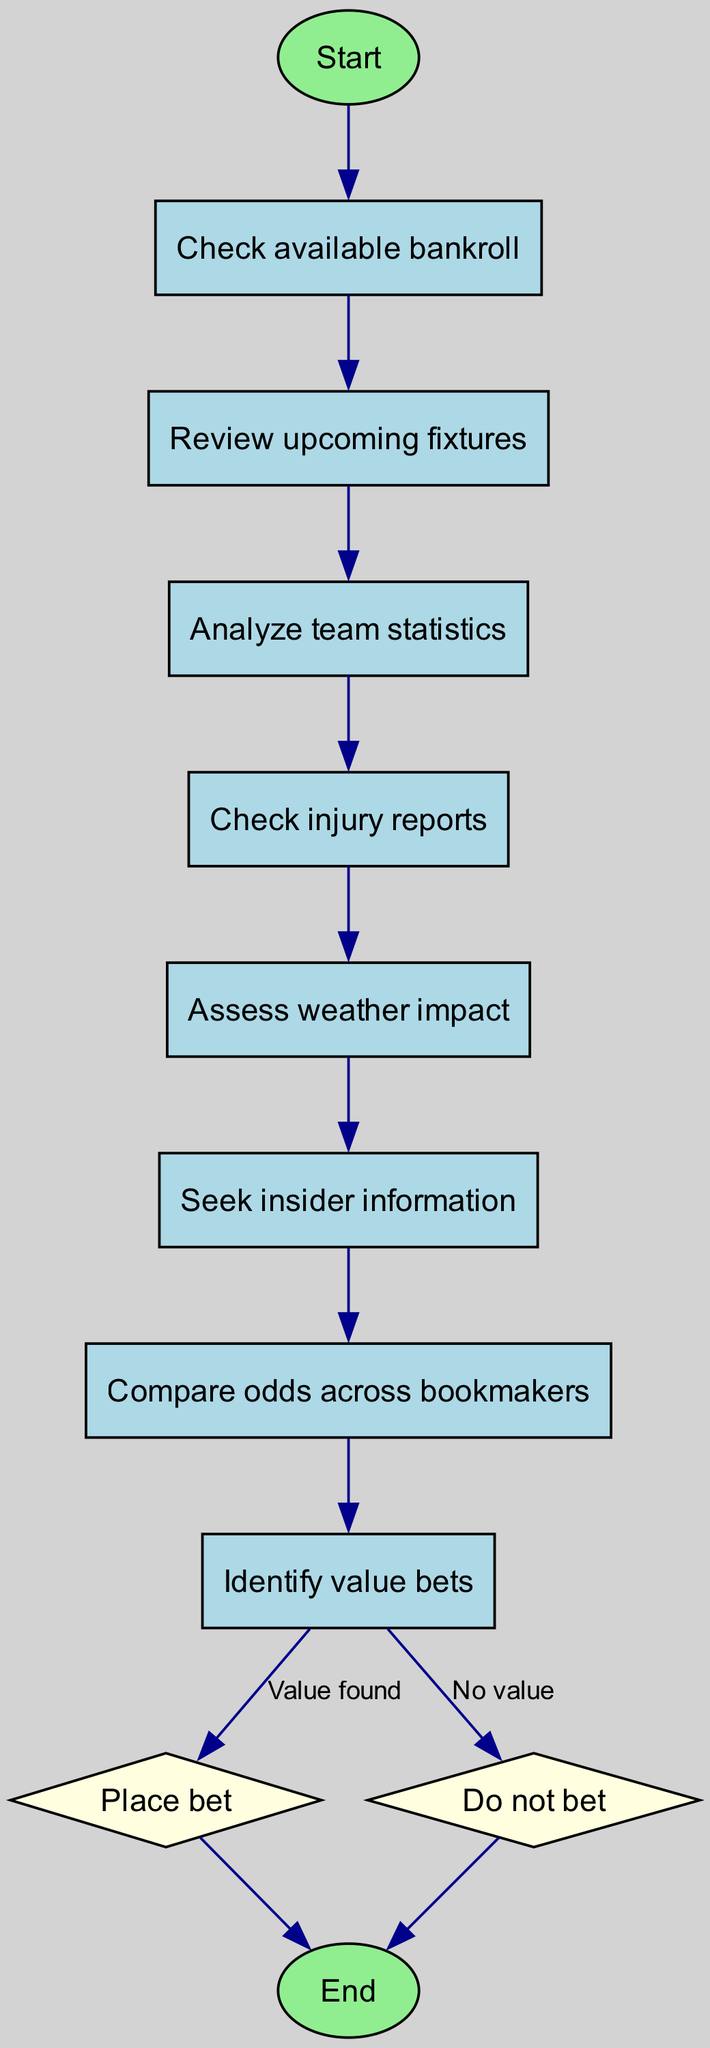What is the first step in the flowchart? The first step in the flowchart is indicated by the starting node. From the diagram, the first node is labeled "Start," making it the first action to take.
Answer: Start How many total nodes are present in the diagram? To find the total number of nodes, we can count each unique element in the diagram. The elements section lists 12 nodes in total.
Answer: 12 What comes after reviewing upcoming fixtures? The flowchart indicates that after reviewing upcoming fixtures, the next step is "Analyze team statistics," as represented by the connecting arrow leading to that node.
Answer: Analyze team statistics What is the decision point in the flowchart? The flowchart includes decision points where choices are made. In this diagram, "Place bet" and "Do not bet" nodes are diamond-shaped, indicating decision points.
Answer: Place bet, Do not bet What condition leads to placing a bet? The condition that results in placing a bet is when a "Value bet" is identified, indicated by the edge labeled "Value found" that connects to the "Place bet" node from the "Identify value bets" node.
Answer: Value found Which node assesses weather impact? In the flowchart, the node responsible for assessing weather impact is clearly listed as "Assess weather impact," following the "Check injury reports" node.
Answer: Assess weather impact How do you move from checking injuries to the next step? From the "Check injury reports" node, the next step is reached by the connecting arrow that leads directly to the "Assess weather impact." This shows the flow from one task to another.
Answer: Assess weather impact If there are no value bets, what will happen? If there are no value bets identified, the flowchart directs to the node "Do not bet." This is determined by the edge labeled "No value" leading to that specific node.
Answer: Do not bet What is the final action taken in the diagram? The final action taken in the flowchart is indicated at the end node, which is labeled "End." This signifies the conclusion of the decision-making process.
Answer: End 